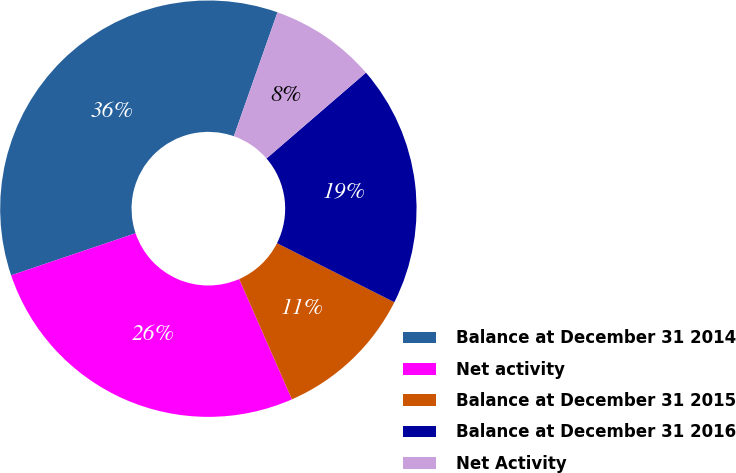<chart> <loc_0><loc_0><loc_500><loc_500><pie_chart><fcel>Balance at December 31 2014<fcel>Net activity<fcel>Balance at December 31 2015<fcel>Balance at December 31 2016<fcel>Net Activity<nl><fcel>35.58%<fcel>26.39%<fcel>11.01%<fcel>18.75%<fcel>8.28%<nl></chart> 